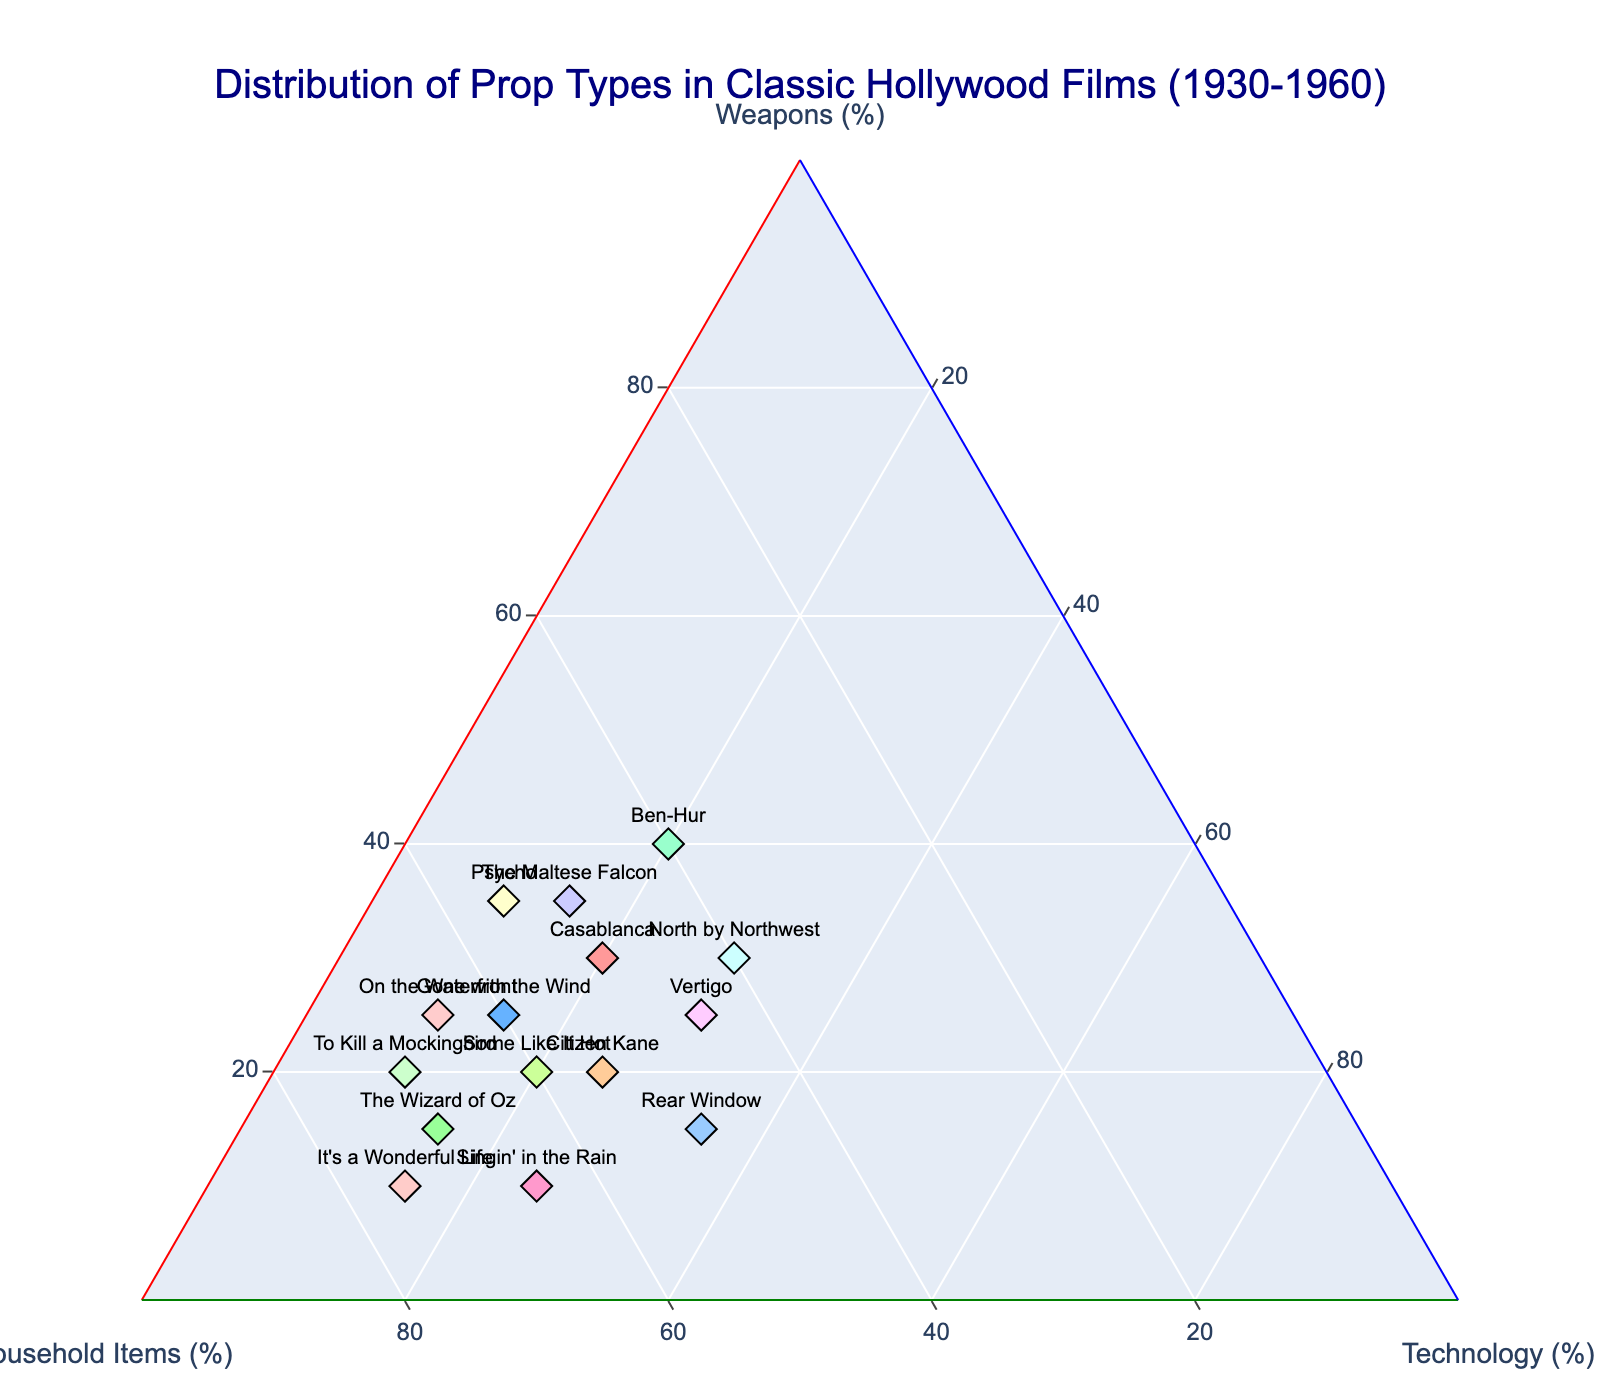What are the titles of the films represented in the plot? The titles of the films are annotated next to the points on the ternary plot. By viewing the plot, you can see all the titles.
Answer: Casablanca, Gone with the Wind, The Wizard of Oz, Citizen Kane, Singin' in the Rain, Rear Window, Some Like It Hot, Vertigo, Ben-Hur, Psycho, The Maltese Falcon, It's a Wonderful Life, To Kill a Mockingbird, North by Northwest, On the Waterfront Which film has the highest percentage of weapons? The film with the highest percentage of weapons is represented by the point closest to the "Weapons (%)" axis. In this plot, it is Ben-Hur with 40% of weapons.
Answer: Ben-Hur What is the distribution of props in "Gone with the Wind"? To find the distribution of props in "Gone with the Wind", locate its point on the ternary plot and read the percentages for each category: Weapons, Household items, and Technology from the three axes.
Answer: Weapons: 25, Household items: 60, Technology: 15 Which films have an equal percentage of Technology props? To answer this, identify films located along the "Technology (%)" axis with the same value for Technology. Both films should lie along a horizontal plane at the same height within the Technology axis. In the plot, these films are "Gone with the Wind", "The Wizard of Oz", "Casablanca", "Ben-Hur", and "The Maltese Falcon" with 15% each, and "On the Waterfront" and "To Kill a Mockingbird" with 10% each.
Answer: Gone with the Wind, The Wizard of Oz, Casablanca, Ben-Hur, The Maltese Falcon, On the Waterfront, To Kill a Mockingbird Are there any films that have more Household items than any other prop type? If so, which ones? Locate films where the points are closer to the "Household Items (%)" axis than to the other two axes. These points will indicate that Household items make up the largest proportion of props. The films that satisfy this condition are: "Gone with the Wind", "The Wizard of Oz", "Citizen Kane", "Singin' in the Rain", "Some Like It Hot", "It's a Wonderful Life", "To Kill a Mockingbird", and "On the Waterfront".
Answer: Gone with the Wind, The Wizard of Oz, Citizen Kane, Singin' in the Rain, Some Like It Hot, It's a Wonderful Life, To Kill a Mockingbird, On the Waterfront Comparing "Rear Window" and "Vertigo", which film has a higher percentage of Technology props? Locate the points for "Rear Window" and "Vertigo" on the ternary plot and compare their positions relative to the "Technology (%)" axis. "Rear Window" shows 35% Technology, whereas "Vertigo" shows 30% Technology. Therefore, "Rear Window" has a higher percentage of Technology props.
Answer: Rear Window What is the average percentage of Household items among all the films? Calculate the average by summing up all the percentages of Household items and then dividing by the number of films. The total percentage is 50 + 60 + 70 + 55 + 65 + 50 + 60 + 45 + 40 + 55 + 50 + 75 + 70 + 40 + 65 = 800. The number of films is 15. Therefore, the average percentage is 800 / 15 ≈ 53.33.
Answer: 53.33 Which film is closest to having an equal distribution of all three prop types? The film closest to the center of the ternary plot (where all three prop types would sum to roughly equal percentages) should be identified. "North by Northwest" has nearly equal values of 30%, 40%, and 30%, making it closest to equal distribution.
Answer: North by Northwest 